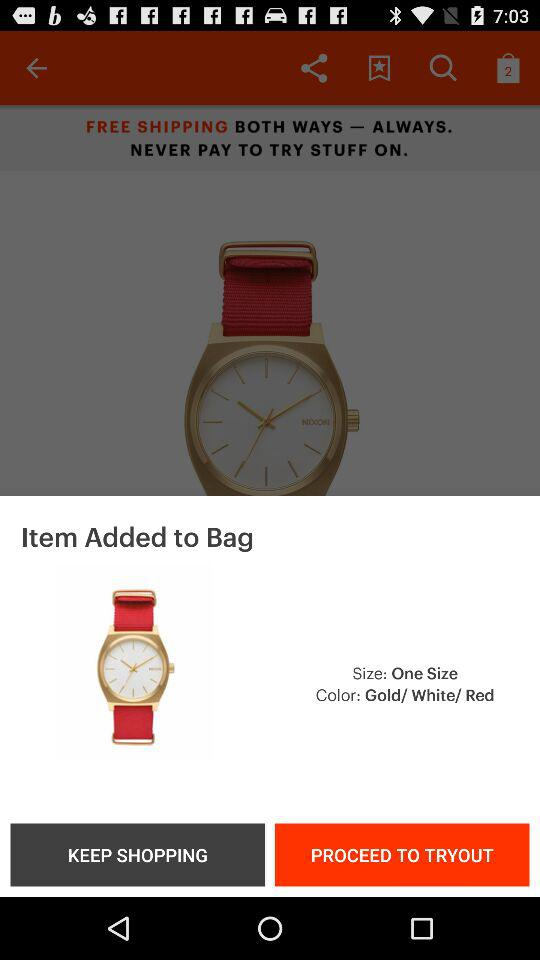How many colors are available for the watch?
Answer the question using a single word or phrase. 3 